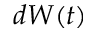Convert formula to latex. <formula><loc_0><loc_0><loc_500><loc_500>d W ( t )</formula> 